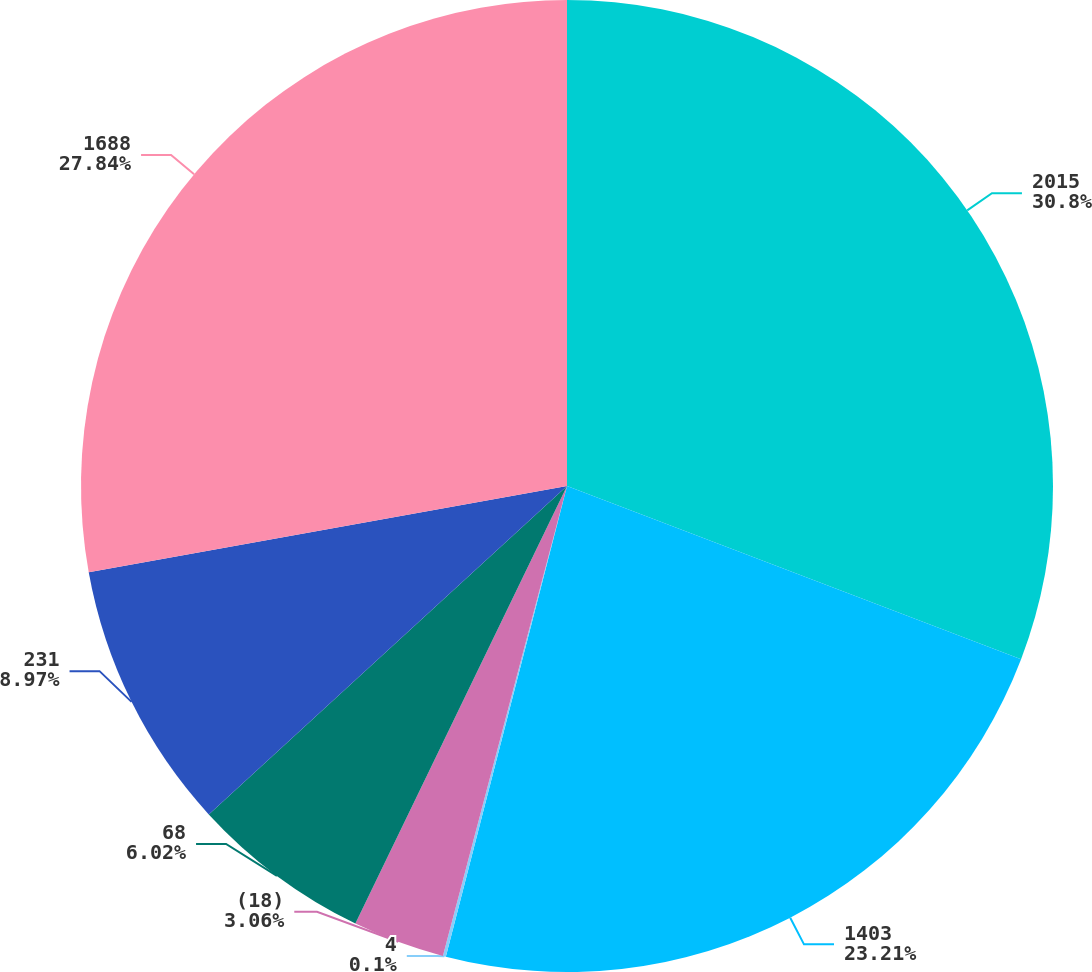Convert chart to OTSL. <chart><loc_0><loc_0><loc_500><loc_500><pie_chart><fcel>2015<fcel>1403<fcel>4<fcel>(18)<fcel>68<fcel>231<fcel>1688<nl><fcel>30.8%<fcel>23.21%<fcel>0.1%<fcel>3.06%<fcel>6.02%<fcel>8.97%<fcel>27.84%<nl></chart> 